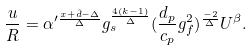<formula> <loc_0><loc_0><loc_500><loc_500>\frac { u } { R } = \alpha ^ { \prime \frac { x + \tilde { d } - \Delta } { \Delta } } g _ { s } ^ { \frac { 4 ( k - 1 ) } { \Delta } } ( \frac { d _ { p } } { c _ { p } } g _ { f } ^ { 2 } ) ^ { \frac { - 2 } { \Delta } } U ^ { \beta } .</formula> 